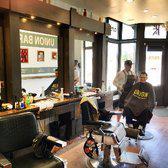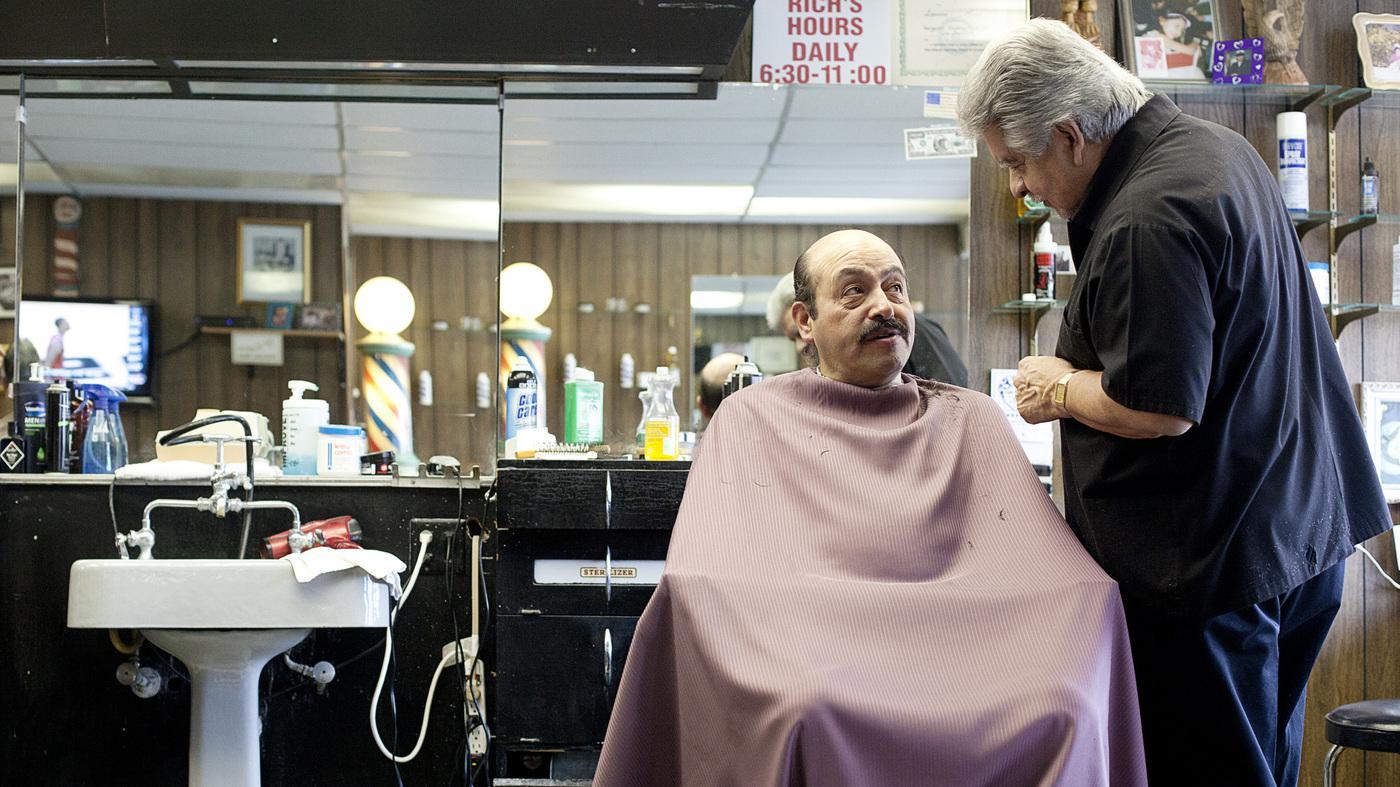The first image is the image on the left, the second image is the image on the right. Examine the images to the left and right. Is the description "There are at least four people in the image on the right." accurate? Answer yes or no. No. 